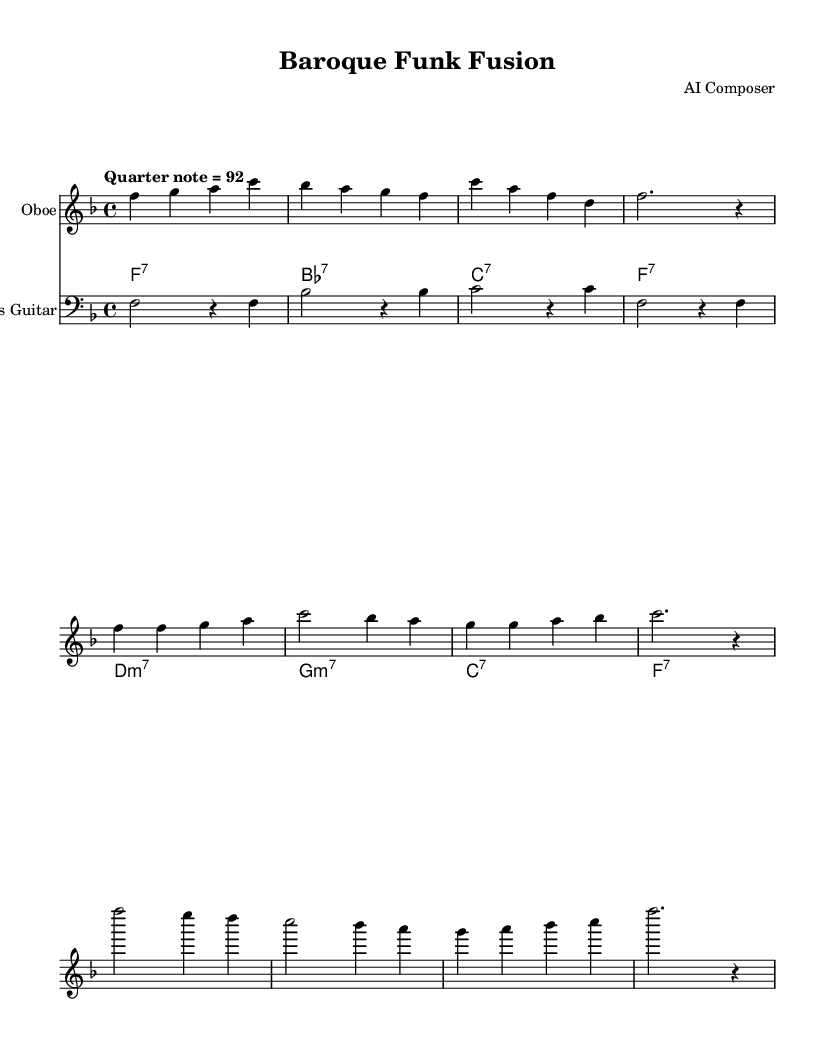What is the key signature of this music? The key signature shows one flat, which indicates the key of F major. You can determine the key by looking at the sharp or flat symbols at the beginning of the staff. In this case, there is one flat (B flat), so the key is F major.
Answer: F major What is the time signature of this music? The time signature can be found at the beginning of the score, shown as a fraction. Here, the time signature is 4/4, which means there are four beats in each measure and a quarter note gets one beat.
Answer: 4/4 What is the tempo marking of this music? The tempo is specified in words directly above the music staff, which states "Quarter note = 92". This means that the beat should be played at a speed of 92 quarter notes per minute.
Answer: Quarter note = 92 What is the main instrument featured in this piece? The main instrument is indicated at the beginning of the staff, specifically labeled "Oboe". This is confirmed by the notation and the fact that the oboe section is the first staff shown.
Answer: Oboe How many measures are in the chorus section? To find the number of measures in the chorus, count the measures in the section marked "Chorus". There are four measures indicated in this section of the music.
Answer: 4 What type of harmonies are primarily used in the electric piano part? The electric piano part consists of seventh chords, as shown by the chord symbols written above the staff. This can be determined by looking at the chord notations which indicate their seventh chord types such as F7 and B flat7.
Answer: Seventh chords What musical genre does this piece represent? The title indicates that this composition is a "Baroque Funk Fusion", combining elements of Baroque music with the rhythm and style of funk. This is signified by the title and the nature of the instrumentation.
Answer: Baroque Funk Fusion 